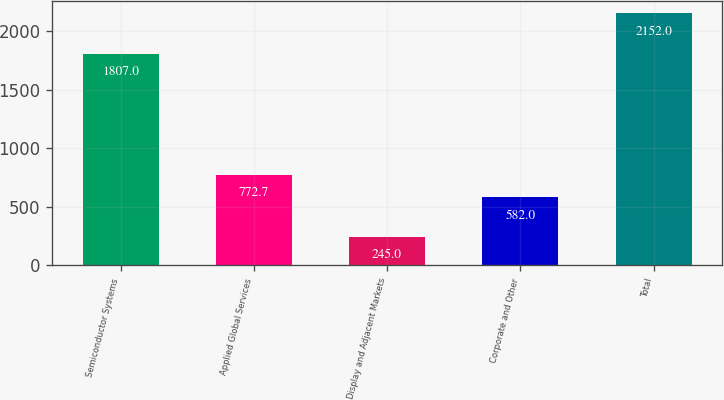Convert chart to OTSL. <chart><loc_0><loc_0><loc_500><loc_500><bar_chart><fcel>Semiconductor Systems<fcel>Applied Global Services<fcel>Display and Adjacent Markets<fcel>Corporate and Other<fcel>Total<nl><fcel>1807<fcel>772.7<fcel>245<fcel>582<fcel>2152<nl></chart> 